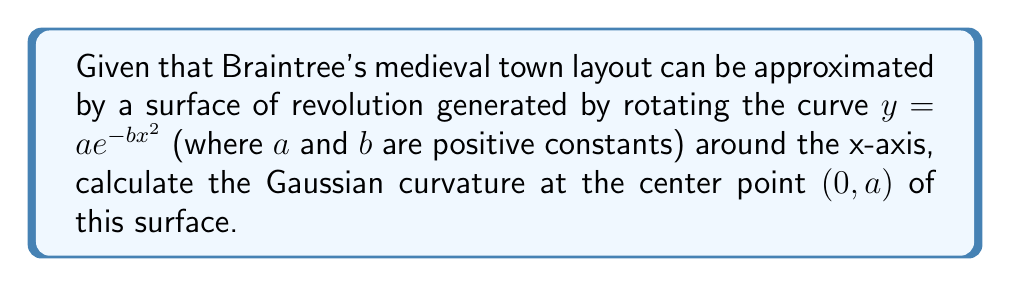Teach me how to tackle this problem. To find the Gaussian curvature of the surface at the center point, we need to follow these steps:

1) The surface of revolution is given by:
   $$X(u,v) = (u, ae^{-bu^2}\cos v, ae^{-bu^2}\sin v)$$

2) Calculate the first fundamental form coefficients:
   $$E = 1 + (-2abu e^{-bu^2})^2$$
   $$F = 0$$
   $$G = (ae^{-bu^2})^2$$

3) Calculate the second fundamental form coefficients:
   $$L = \frac{-2ab e^{-bu^2} + 4ab^2u^2 e^{-bu^2}}{\sqrt{1 + (-2abu e^{-bu^2})^2}}$$
   $$M = 0$$
   $$N = \frac{ae^{-bu^2}}{\sqrt{1 + (-2abu e^{-bu^2})^2}}$$

4) The Gaussian curvature is given by:
   $$K = \frac{LN - M^2}{EG - F^2}$$

5) At the center point $(0,a)$, we have $u=0$. Substituting this:
   $$E = 1, G = a^2, L = -2ab, N = a$$

6) Therefore, at $(0,a)$:
   $$K = \frac{(-2ab)(a)}{(1)(a^2)} = -\frac{2b}{a}$$

This negative value indicates that the center of Braintree's medieval layout, when modeled this way, has a saddle-like shape.
Answer: $-\frac{2b}{a}$ 